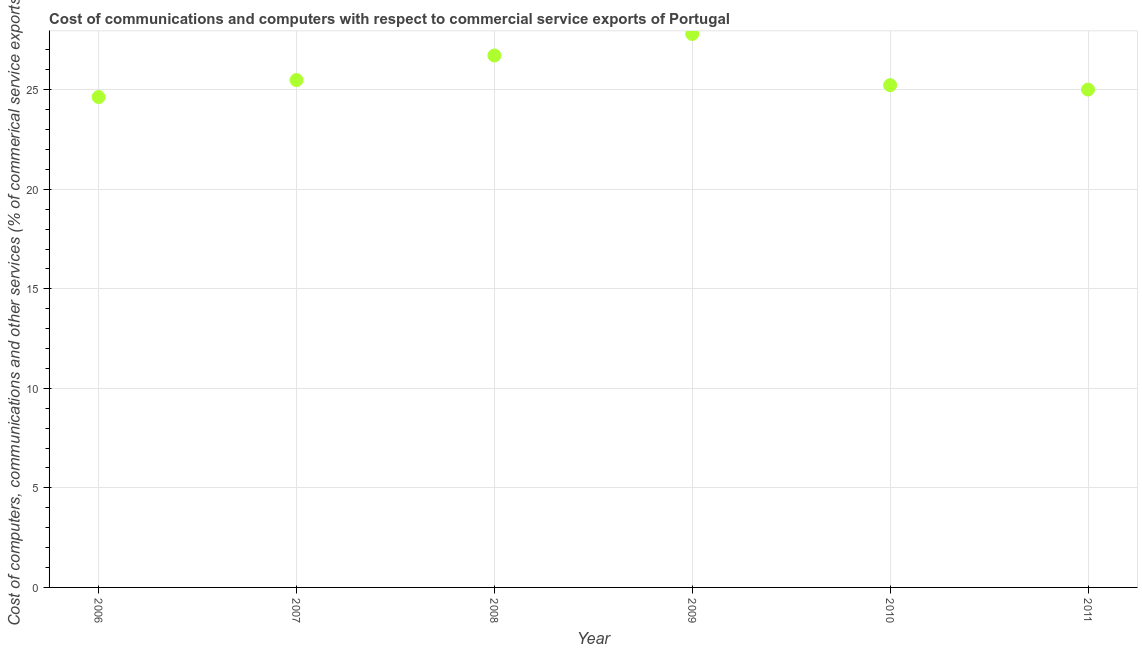What is the cost of communications in 2011?
Offer a terse response. 25.01. Across all years, what is the maximum  computer and other services?
Offer a terse response. 27.8. Across all years, what is the minimum  computer and other services?
Offer a terse response. 24.63. In which year was the  computer and other services minimum?
Give a very brief answer. 2006. What is the sum of the cost of communications?
Provide a short and direct response. 154.89. What is the difference between the cost of communications in 2007 and 2010?
Provide a short and direct response. 0.26. What is the average  computer and other services per year?
Your answer should be very brief. 25.82. What is the median cost of communications?
Ensure brevity in your answer.  25.36. In how many years, is the  computer and other services greater than 5 %?
Keep it short and to the point. 6. Do a majority of the years between 2009 and 2010 (inclusive) have  computer and other services greater than 22 %?
Offer a very short reply. Yes. What is the ratio of the  computer and other services in 2006 to that in 2008?
Offer a terse response. 0.92. Is the difference between the  computer and other services in 2009 and 2010 greater than the difference between any two years?
Your answer should be compact. No. What is the difference between the highest and the second highest cost of communications?
Your answer should be compact. 1.08. Is the sum of the  computer and other services in 2006 and 2007 greater than the maximum  computer and other services across all years?
Provide a short and direct response. Yes. What is the difference between the highest and the lowest  computer and other services?
Your response must be concise. 3.17. In how many years, is the  computer and other services greater than the average  computer and other services taken over all years?
Provide a short and direct response. 2. What is the difference between two consecutive major ticks on the Y-axis?
Give a very brief answer. 5. Does the graph contain any zero values?
Provide a short and direct response. No. What is the title of the graph?
Ensure brevity in your answer.  Cost of communications and computers with respect to commercial service exports of Portugal. What is the label or title of the Y-axis?
Your answer should be compact. Cost of computers, communications and other services (% of commerical service exports). What is the Cost of computers, communications and other services (% of commerical service exports) in 2006?
Provide a short and direct response. 24.63. What is the Cost of computers, communications and other services (% of commerical service exports) in 2007?
Make the answer very short. 25.49. What is the Cost of computers, communications and other services (% of commerical service exports) in 2008?
Your response must be concise. 26.72. What is the Cost of computers, communications and other services (% of commerical service exports) in 2009?
Your response must be concise. 27.8. What is the Cost of computers, communications and other services (% of commerical service exports) in 2010?
Provide a succinct answer. 25.23. What is the Cost of computers, communications and other services (% of commerical service exports) in 2011?
Make the answer very short. 25.01. What is the difference between the Cost of computers, communications and other services (% of commerical service exports) in 2006 and 2007?
Give a very brief answer. -0.85. What is the difference between the Cost of computers, communications and other services (% of commerical service exports) in 2006 and 2008?
Your answer should be compact. -2.09. What is the difference between the Cost of computers, communications and other services (% of commerical service exports) in 2006 and 2009?
Keep it short and to the point. -3.17. What is the difference between the Cost of computers, communications and other services (% of commerical service exports) in 2006 and 2010?
Provide a succinct answer. -0.6. What is the difference between the Cost of computers, communications and other services (% of commerical service exports) in 2006 and 2011?
Offer a very short reply. -0.38. What is the difference between the Cost of computers, communications and other services (% of commerical service exports) in 2007 and 2008?
Ensure brevity in your answer.  -1.23. What is the difference between the Cost of computers, communications and other services (% of commerical service exports) in 2007 and 2009?
Provide a short and direct response. -2.31. What is the difference between the Cost of computers, communications and other services (% of commerical service exports) in 2007 and 2010?
Provide a succinct answer. 0.26. What is the difference between the Cost of computers, communications and other services (% of commerical service exports) in 2007 and 2011?
Provide a short and direct response. 0.48. What is the difference between the Cost of computers, communications and other services (% of commerical service exports) in 2008 and 2009?
Offer a very short reply. -1.08. What is the difference between the Cost of computers, communications and other services (% of commerical service exports) in 2008 and 2010?
Offer a very short reply. 1.49. What is the difference between the Cost of computers, communications and other services (% of commerical service exports) in 2008 and 2011?
Offer a very short reply. 1.71. What is the difference between the Cost of computers, communications and other services (% of commerical service exports) in 2009 and 2010?
Provide a short and direct response. 2.57. What is the difference between the Cost of computers, communications and other services (% of commerical service exports) in 2009 and 2011?
Your answer should be compact. 2.79. What is the difference between the Cost of computers, communications and other services (% of commerical service exports) in 2010 and 2011?
Give a very brief answer. 0.22. What is the ratio of the Cost of computers, communications and other services (% of commerical service exports) in 2006 to that in 2008?
Your answer should be very brief. 0.92. What is the ratio of the Cost of computers, communications and other services (% of commerical service exports) in 2006 to that in 2009?
Provide a short and direct response. 0.89. What is the ratio of the Cost of computers, communications and other services (% of commerical service exports) in 2006 to that in 2011?
Your response must be concise. 0.98. What is the ratio of the Cost of computers, communications and other services (% of commerical service exports) in 2007 to that in 2008?
Your answer should be very brief. 0.95. What is the ratio of the Cost of computers, communications and other services (% of commerical service exports) in 2007 to that in 2009?
Your answer should be very brief. 0.92. What is the ratio of the Cost of computers, communications and other services (% of commerical service exports) in 2007 to that in 2011?
Your answer should be compact. 1.02. What is the ratio of the Cost of computers, communications and other services (% of commerical service exports) in 2008 to that in 2010?
Your answer should be compact. 1.06. What is the ratio of the Cost of computers, communications and other services (% of commerical service exports) in 2008 to that in 2011?
Give a very brief answer. 1.07. What is the ratio of the Cost of computers, communications and other services (% of commerical service exports) in 2009 to that in 2010?
Ensure brevity in your answer.  1.1. What is the ratio of the Cost of computers, communications and other services (% of commerical service exports) in 2009 to that in 2011?
Your answer should be very brief. 1.11. 